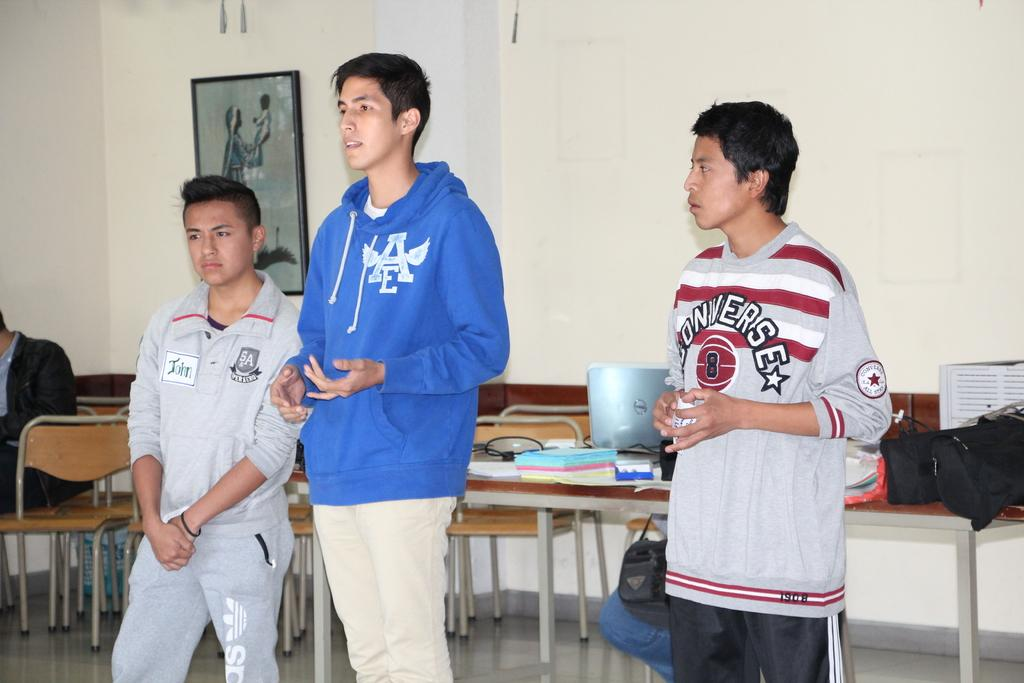<image>
Create a compact narrative representing the image presented. John is standing next to a much taller boy in a blue hoodie with a second boy in a converse sweatshirt looking at them. 